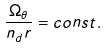Convert formula to latex. <formula><loc_0><loc_0><loc_500><loc_500>\frac { \Omega _ { \theta } } { n _ { d } r } = c o n s t .</formula> 